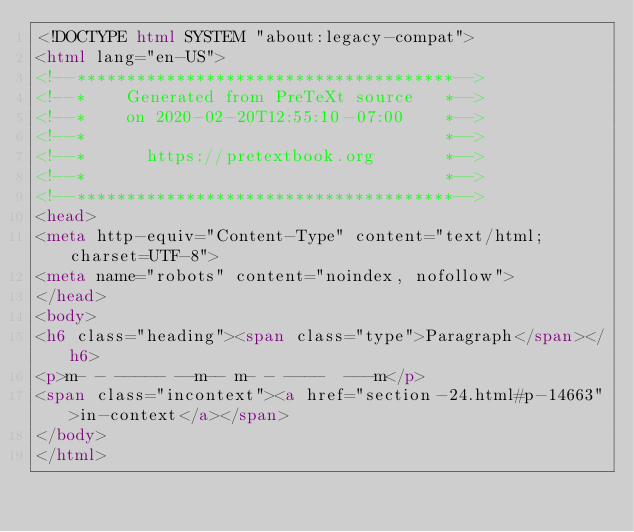Convert code to text. <code><loc_0><loc_0><loc_500><loc_500><_HTML_><!DOCTYPE html SYSTEM "about:legacy-compat">
<html lang="en-US">
<!--**************************************-->
<!--*    Generated from PreTeXt source   *-->
<!--*    on 2020-02-20T12:55:10-07:00    *-->
<!--*                                    *-->
<!--*      https://pretextbook.org       *-->
<!--*                                    *-->
<!--**************************************-->
<head>
<meta http-equiv="Content-Type" content="text/html; charset=UTF-8">
<meta name="robots" content="noindex, nofollow">
</head>
<body>
<h6 class="heading"><span class="type">Paragraph</span></h6>
<p>m- - ----- --m-- m- - ----  ---m</p>
<span class="incontext"><a href="section-24.html#p-14663">in-context</a></span>
</body>
</html>
</code> 